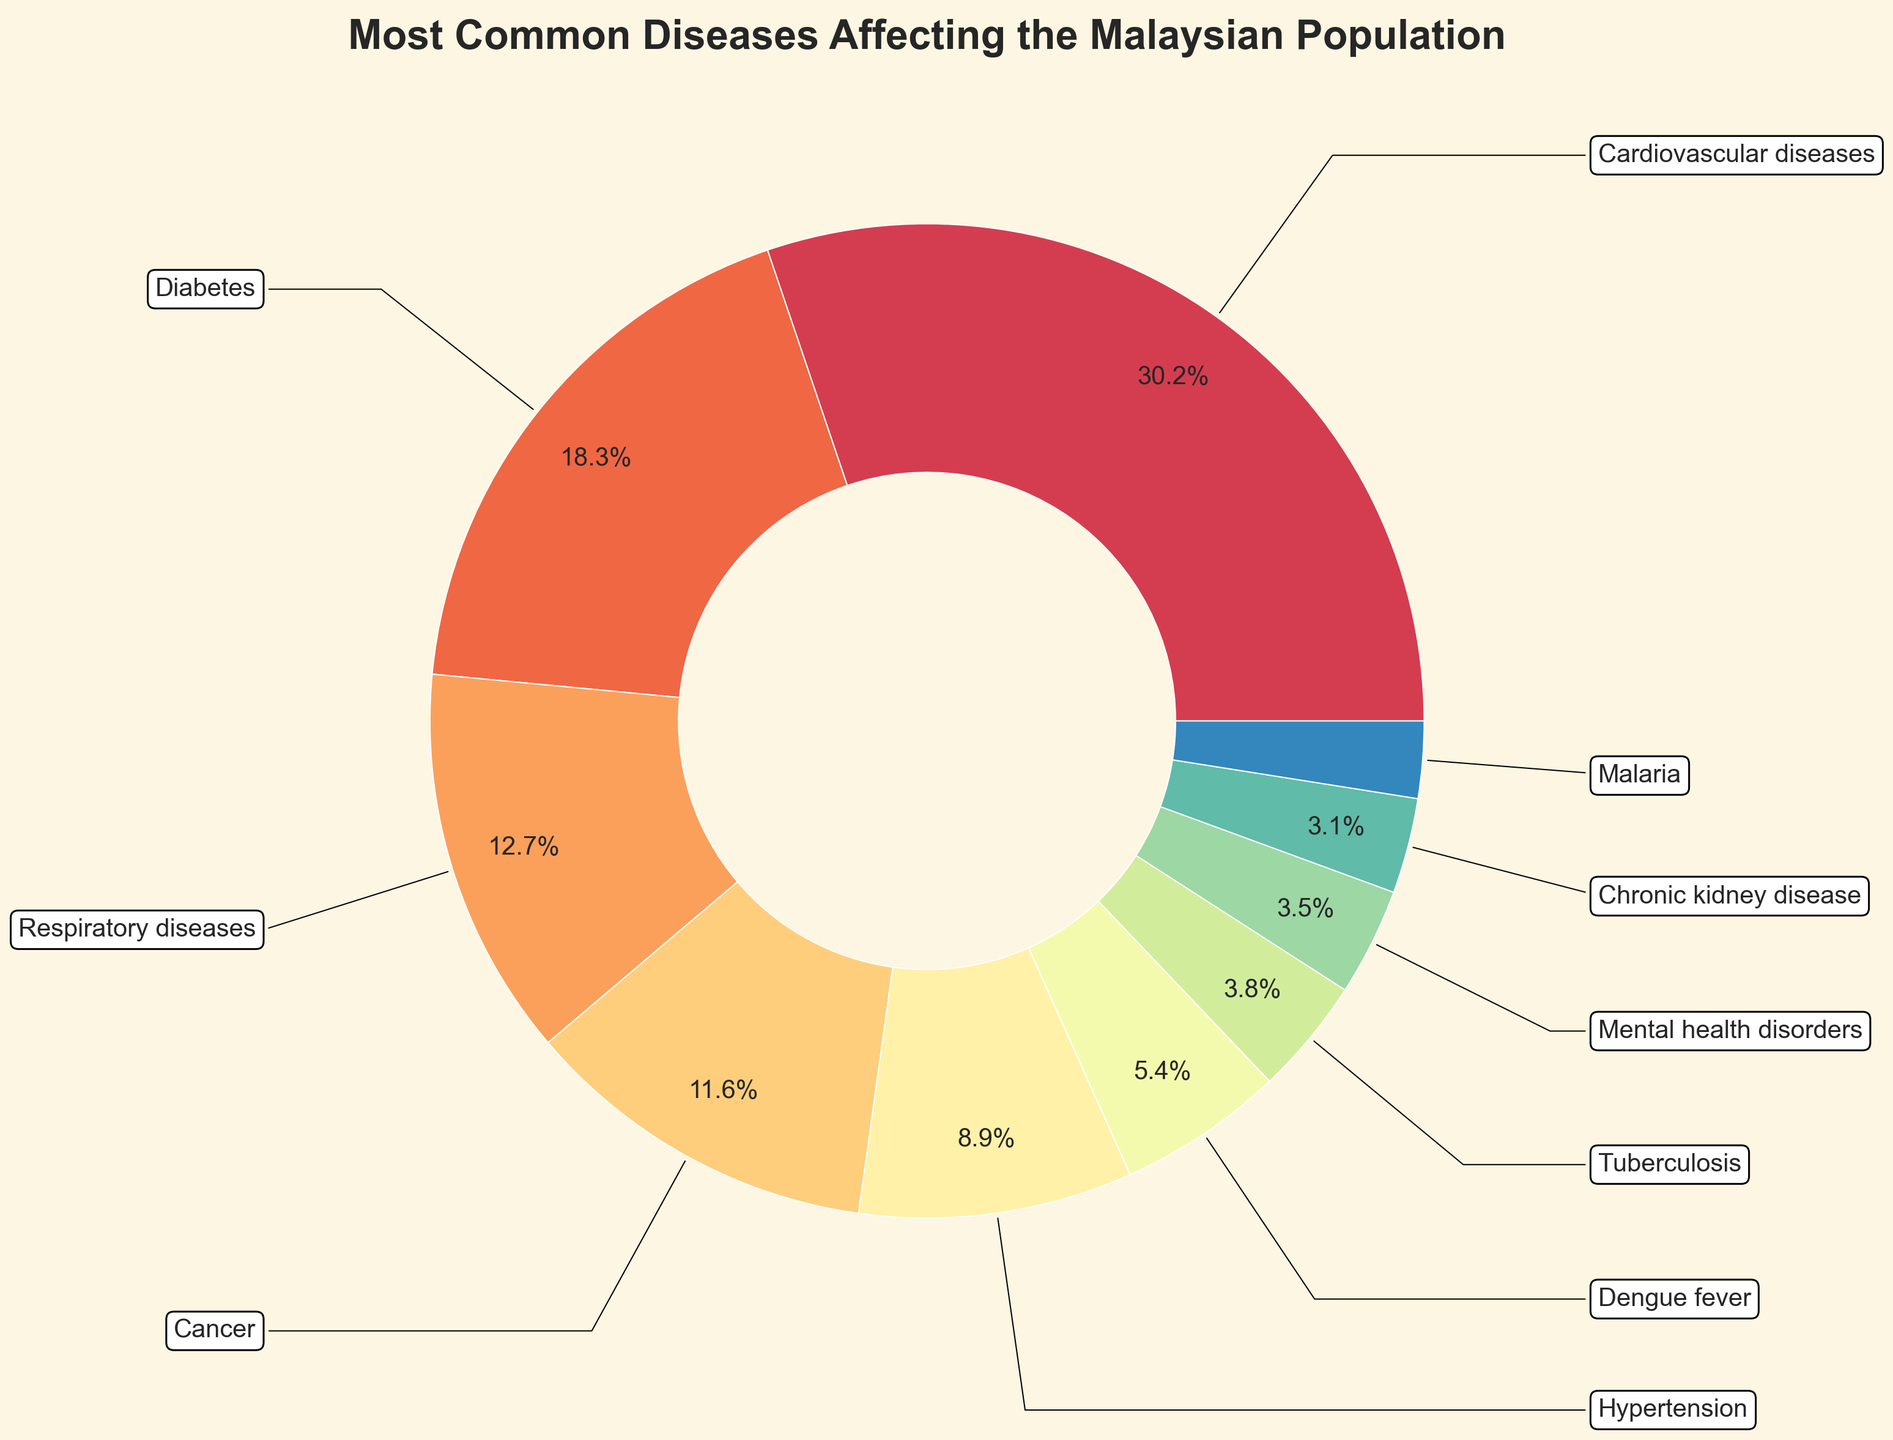Which disease has the highest percentage? To find the disease with the highest percentage, look for the largest sector in the pie chart. The chart shows “Cardiovascular diseases” as the largest sector.
Answer: Cardiovascular diseases What is the combined percentage of diseases with a percentage higher than 10%? Identify the diseases with percentages higher than 10% and sum their values: Cardiovascular diseases (30.2%), Diabetes (18.3%), Respiratory diseases (12.7%), and Cancer (11.6%). Adding them yields 30.2 + 18.3 + 12.7 + 11.6 = 72.8%.
Answer: 72.8% Which disease has a larger percentage, Hypertension or Dengue fever? Compare the sectors corresponding to Hypertension (8.9%) and Dengue fever (5.4%). Since 8.9% > 5.4%, Hypertension has a larger percentage.
Answer: Hypertension What is the smallest category in the chart? Find the smallest sector in the pie chart, which corresponds to Malaria (2.5%).
Answer: Malaria How many diseases have a percentage less than 5%? Identify sectors representing diseases with percentages less than 5%: Tuberculosis (3.8%), Mental health disorders (3.5%), Chronic kidney disease (3.1%), and Malaria (2.5%). This gives a total of four diseases.
Answer: 4 If we combine the percentages for Diabetes and Cancer, would it surpass the percentage for Cardiovascular diseases? Add the percentages for Diabetes (18.3%) and Cancer (11.6%) and compare with Cardiovascular diseases (30.2%). The sum is 18.3 + 11.6 = 29.9%, which is less than 30.2%.
Answer: No Which disease falls between 3% and 4% in terms of percentage? Locate the sector(s) whose percentages fall within the range 3% to 4%. Tuberculosis (3.8%) and Mental health disorders (3.5%) fit this criterion.
Answer: Tuberculosis and Mental health disorders What color represents Diabetes on the pie chart? The pie chart uses distinct colors for each disease. Identify the color section corresponding to Diabetes. Assume Diabetes is marked with its unique color from the Spectral colormap (this specific color detail needs to be visually identified from the chart).
Answer: [Color corresponding to Diabetes, e.g., green] What is the difference in percentage between Respiratory diseases and Chronic kidney disease? Subtract the percentage of Chronic kidney disease (3.1%) from Respiratory diseases (12.7%): 12.7 - 3.1 = 9.6%.
Answer: 9.6% What are the top three most common diseases affecting the Malaysian population according to the chart? Identify the three largest sectors in the pie chart: Cardiovascular diseases (30.2%), Diabetes (18.3%), and Respiratory diseases (12.7%).
Answer: Cardiovascular diseases, Diabetes, Respiratory diseases 